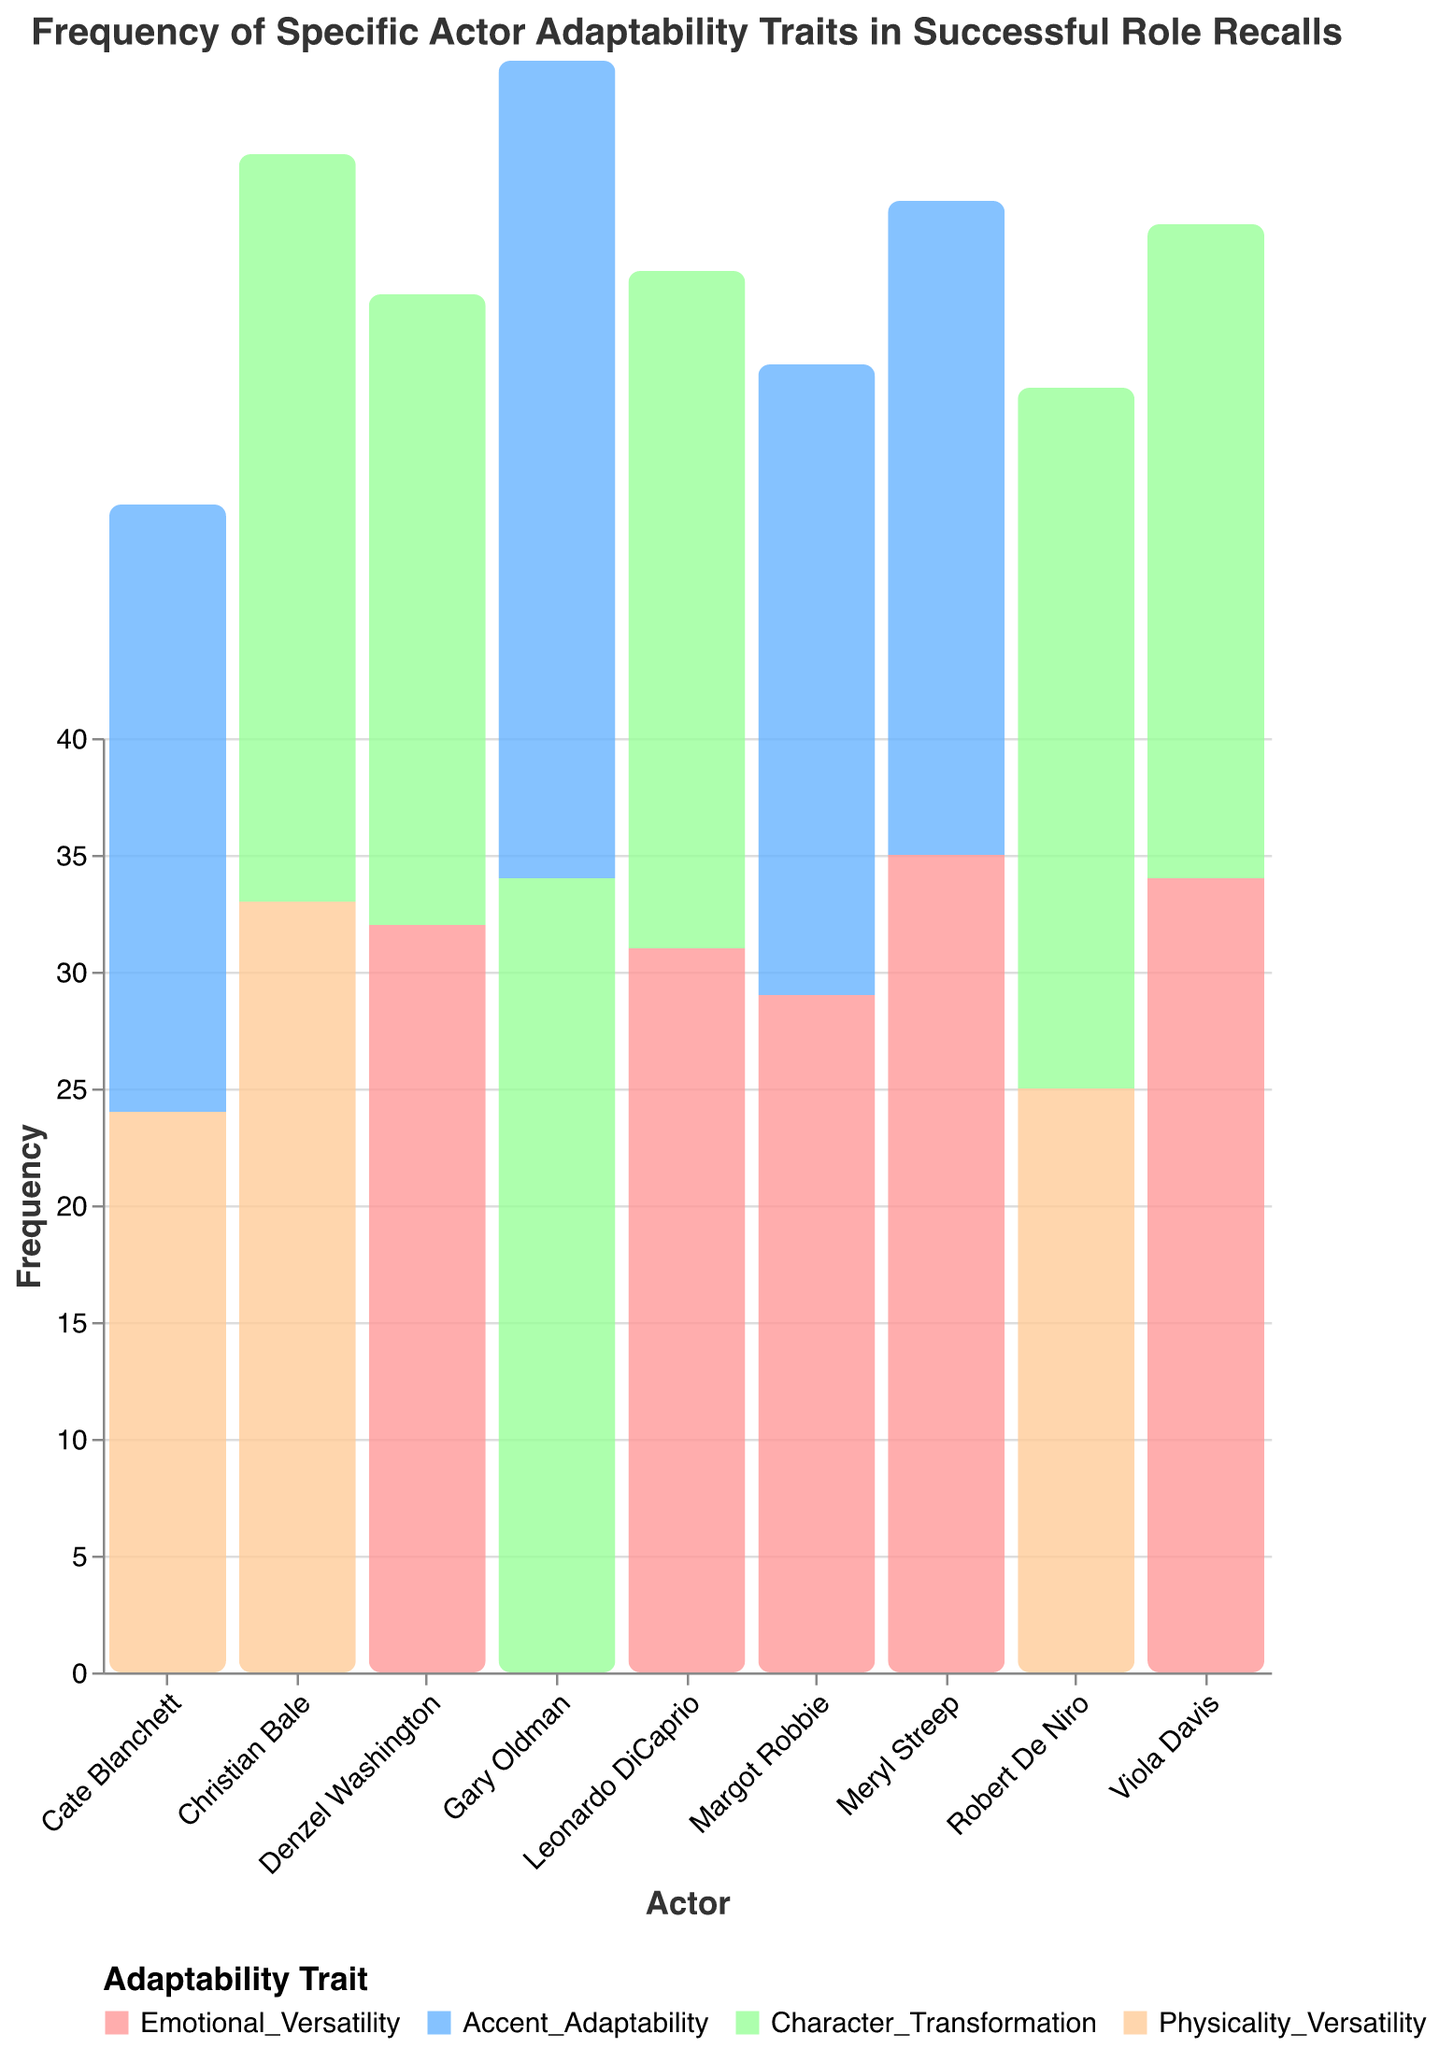What's the title of the figure? The title is displayed at the top of the figure, which is "Frequency of Specific Actor Adaptability Traits in Successful Role Recalls".
Answer: Frequency of Specific Actor Adaptability Traits in Successful Role Recalls Which actor has the highest frequency for Emotional Versatility? By looking at the height of the bars corresponding to Emotional Versatility for each actor, Meryl Streep with a frequency of 35 has the highest.
Answer: Meryl Streep Compare the frequency of Accent Adaptability for Meryl Streep and Gary Oldman. Which one is higher and by how much? Meryl Streep has a frequency of 28 for Accent Adaptability, and Gary Oldman has a frequency of 35. 35 – 28 = 7. Gary Oldman's frequency is higher by 7.
Answer: Gary Oldman by 7 What is the average frequency of Physicality Versatility traits across all actors? The frequencies are 25 (Robert De Niro), 24 (Cate Blanchett), and 33 (Christian Bale). Average = (25 + 24 + 33)/3 = 82/3 ≈ 27.33.
Answer: 27.33 Which actor appears to have the most balanced frequencies across all their traits? Analyzing the heights of the bars for each actor, Christian Bale has Physicality Versatility at 33 and Character Transformation at 32, showing well-balanced performance.
Answer: Christian Bale Identify the actor with the highest frequency in Character Transformation. By observing the height of the bars categorized under Character Transformation, Gary Oldman leads with a frequency of 34.
Answer: Gary Oldman What is the combined frequency of Emotional Versatility for Denzel Washington, Viola Davis, and Leonardo DiCaprio? Sum the frequencies: Denzel Washington (32), Viola Davis (34), Leonardo DiCaprio (31). Total = 32 + 34 + 31 = 97.
Answer: 97 Which trait shows the highest frequency across all actors and who does it belong to? Observing all bars, Emotional Versatility for Meryl Streep peaks at 35, making it the highest frequency.
Answer: Emotional Versatility by Meryl Streep How many actors have a frequency of 30 or higher for Character Transformation? Counting the bars categorized under Character Transformation that are at least 30 high: Robert De Niro (30), Leonardo DiCaprio (29 < 30 - excluded), Christian Bale (32), Gary Oldman (34). Total actors = 3.
Answer: 3 Which actor has the lowest frequency for any trait, and what is that frequency? Cate Blanchett shows the lowest bar under Physicality Versatility with a frequency of 24.
Answer: Cate Blanchett with 24 